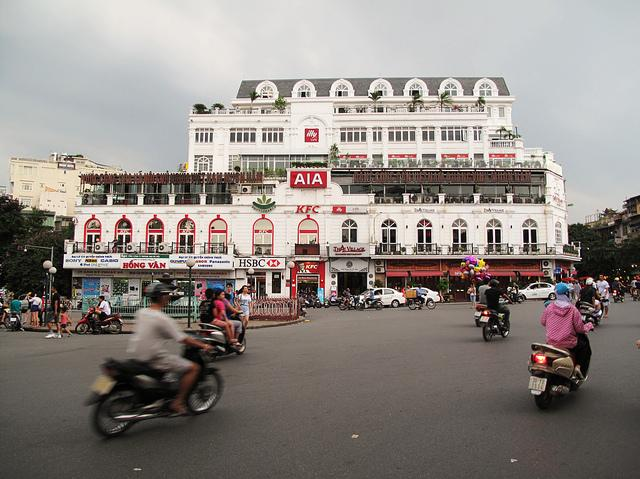What sort of bird meats are sold in this large building among other things?

Choices:
A) chicken
B) dove
C) duck
D) pigeon chicken 